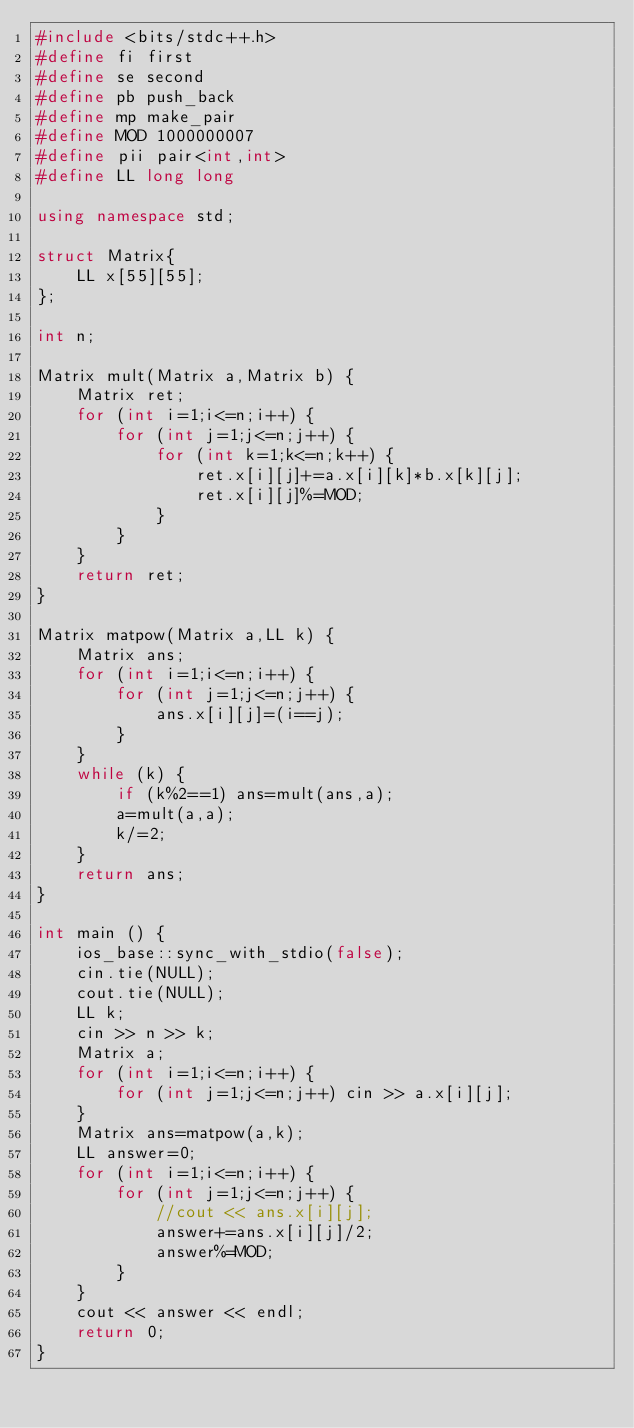<code> <loc_0><loc_0><loc_500><loc_500><_C++_>#include <bits/stdc++.h>
#define fi first
#define se second
#define pb push_back
#define mp make_pair
#define MOD 1000000007
#define pii pair<int,int>
#define LL long long

using namespace std;

struct Matrix{
    LL x[55][55];
};

int n;

Matrix mult(Matrix a,Matrix b) {
    Matrix ret;
    for (int i=1;i<=n;i++) {
        for (int j=1;j<=n;j++) {
            for (int k=1;k<=n;k++) {
                ret.x[i][j]+=a.x[i][k]*b.x[k][j];
                ret.x[i][j]%=MOD;
            }
        }
    }
    return ret;
}

Matrix matpow(Matrix a,LL k) {
    Matrix ans;
    for (int i=1;i<=n;i++) {
        for (int j=1;j<=n;j++) {
            ans.x[i][j]=(i==j);
        }
    }
    while (k) {
        if (k%2==1) ans=mult(ans,a);
        a=mult(a,a);
        k/=2; 
    }
    return ans;
}

int main () {
    ios_base::sync_with_stdio(false);
    cin.tie(NULL);
    cout.tie(NULL);
    LL k;
    cin >> n >> k;
    Matrix a;
    for (int i=1;i<=n;i++) {
        for (int j=1;j<=n;j++) cin >> a.x[i][j];
    }
    Matrix ans=matpow(a,k);
    LL answer=0;
    for (int i=1;i<=n;i++) {
        for (int j=1;j<=n;j++) {
            //cout << ans.x[i][j];
            answer+=ans.x[i][j]/2;
            answer%=MOD;
        }
    }
    cout << answer << endl;
    return 0;
}
</code> 